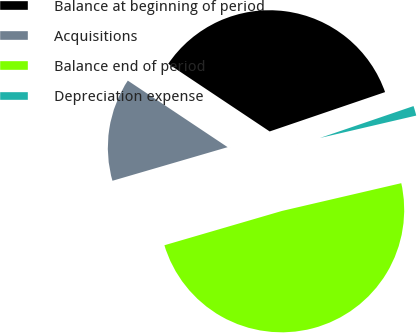<chart> <loc_0><loc_0><loc_500><loc_500><pie_chart><fcel>Balance at beginning of period<fcel>Acquisitions<fcel>Balance end of period<fcel>Depreciation expense<nl><fcel>35.41%<fcel>13.88%<fcel>49.12%<fcel>1.59%<nl></chart> 